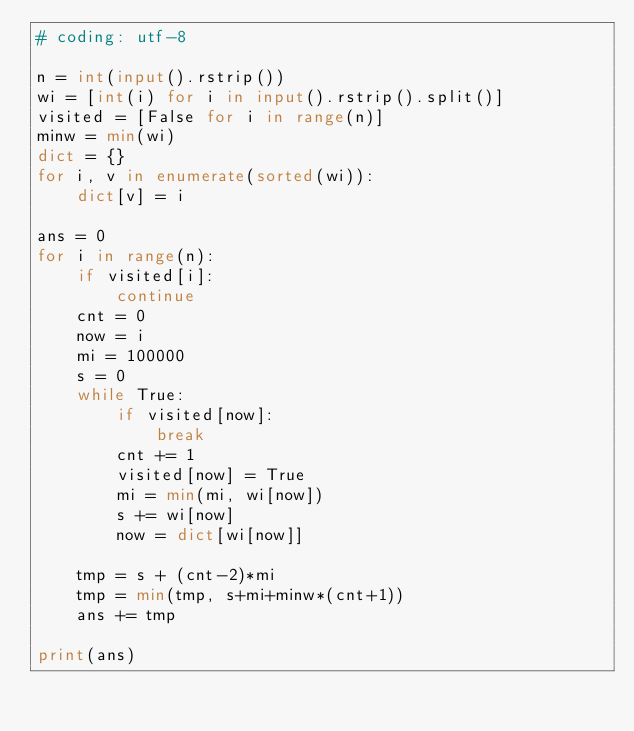Convert code to text. <code><loc_0><loc_0><loc_500><loc_500><_Python_># coding: utf-8

n = int(input().rstrip())
wi = [int(i) for i in input().rstrip().split()]
visited = [False for i in range(n)]
minw = min(wi)
dict = {}
for i, v in enumerate(sorted(wi)):
    dict[v] = i

ans = 0
for i in range(n):
    if visited[i]:
        continue
    cnt = 0
    now = i
    mi = 100000
    s = 0
    while True:
        if visited[now]:
            break
        cnt += 1
        visited[now] = True
        mi = min(mi, wi[now])
        s += wi[now]
        now = dict[wi[now]]
    
    tmp = s + (cnt-2)*mi
    tmp = min(tmp, s+mi+minw*(cnt+1))
    ans += tmp

print(ans)
    
</code> 